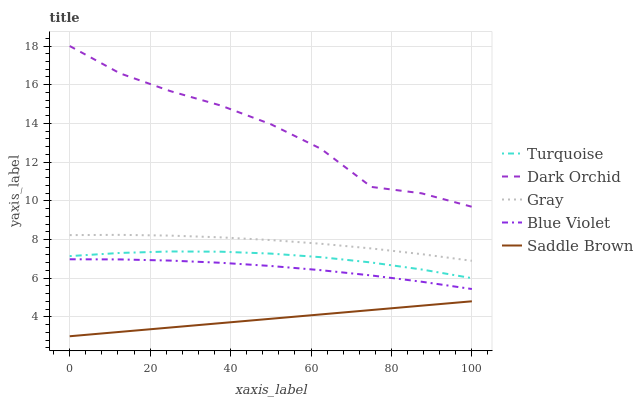Does Saddle Brown have the minimum area under the curve?
Answer yes or no. Yes. Does Dark Orchid have the maximum area under the curve?
Answer yes or no. Yes. Does Turquoise have the minimum area under the curve?
Answer yes or no. No. Does Turquoise have the maximum area under the curve?
Answer yes or no. No. Is Saddle Brown the smoothest?
Answer yes or no. Yes. Is Dark Orchid the roughest?
Answer yes or no. Yes. Is Turquoise the smoothest?
Answer yes or no. No. Is Turquoise the roughest?
Answer yes or no. No. Does Saddle Brown have the lowest value?
Answer yes or no. Yes. Does Turquoise have the lowest value?
Answer yes or no. No. Does Dark Orchid have the highest value?
Answer yes or no. Yes. Does Turquoise have the highest value?
Answer yes or no. No. Is Blue Violet less than Gray?
Answer yes or no. Yes. Is Turquoise greater than Saddle Brown?
Answer yes or no. Yes. Does Blue Violet intersect Gray?
Answer yes or no. No. 